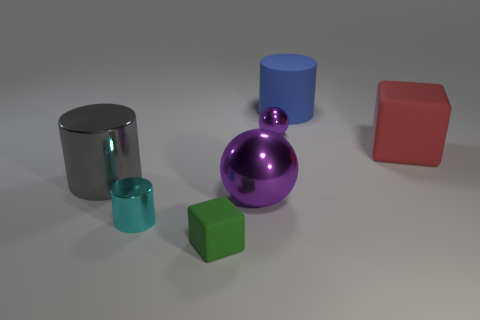How many cubes are either tiny cyan objects or gray things?
Offer a terse response. 0. There is a rubber cube that is the same size as the blue cylinder; what is its color?
Provide a short and direct response. Red. There is a big matte cylinder to the right of the small shiny thing that is in front of the large gray metallic cylinder; are there any matte blocks that are behind it?
Give a very brief answer. No. The red object is what size?
Ensure brevity in your answer.  Large. How many objects are either green rubber objects or small brown metal cylinders?
Give a very brief answer. 1. The tiny ball that is made of the same material as the large ball is what color?
Your answer should be very brief. Purple. There is a rubber thing on the left side of the large rubber cylinder; is it the same shape as the big blue matte object?
Provide a short and direct response. No. What number of things are big cylinders to the right of the cyan metal cylinder or big things to the left of the big blue cylinder?
Ensure brevity in your answer.  3. There is a small rubber thing that is the same shape as the large red matte object; what is its color?
Offer a terse response. Green. Is there anything else that has the same shape as the red object?
Offer a terse response. Yes. 